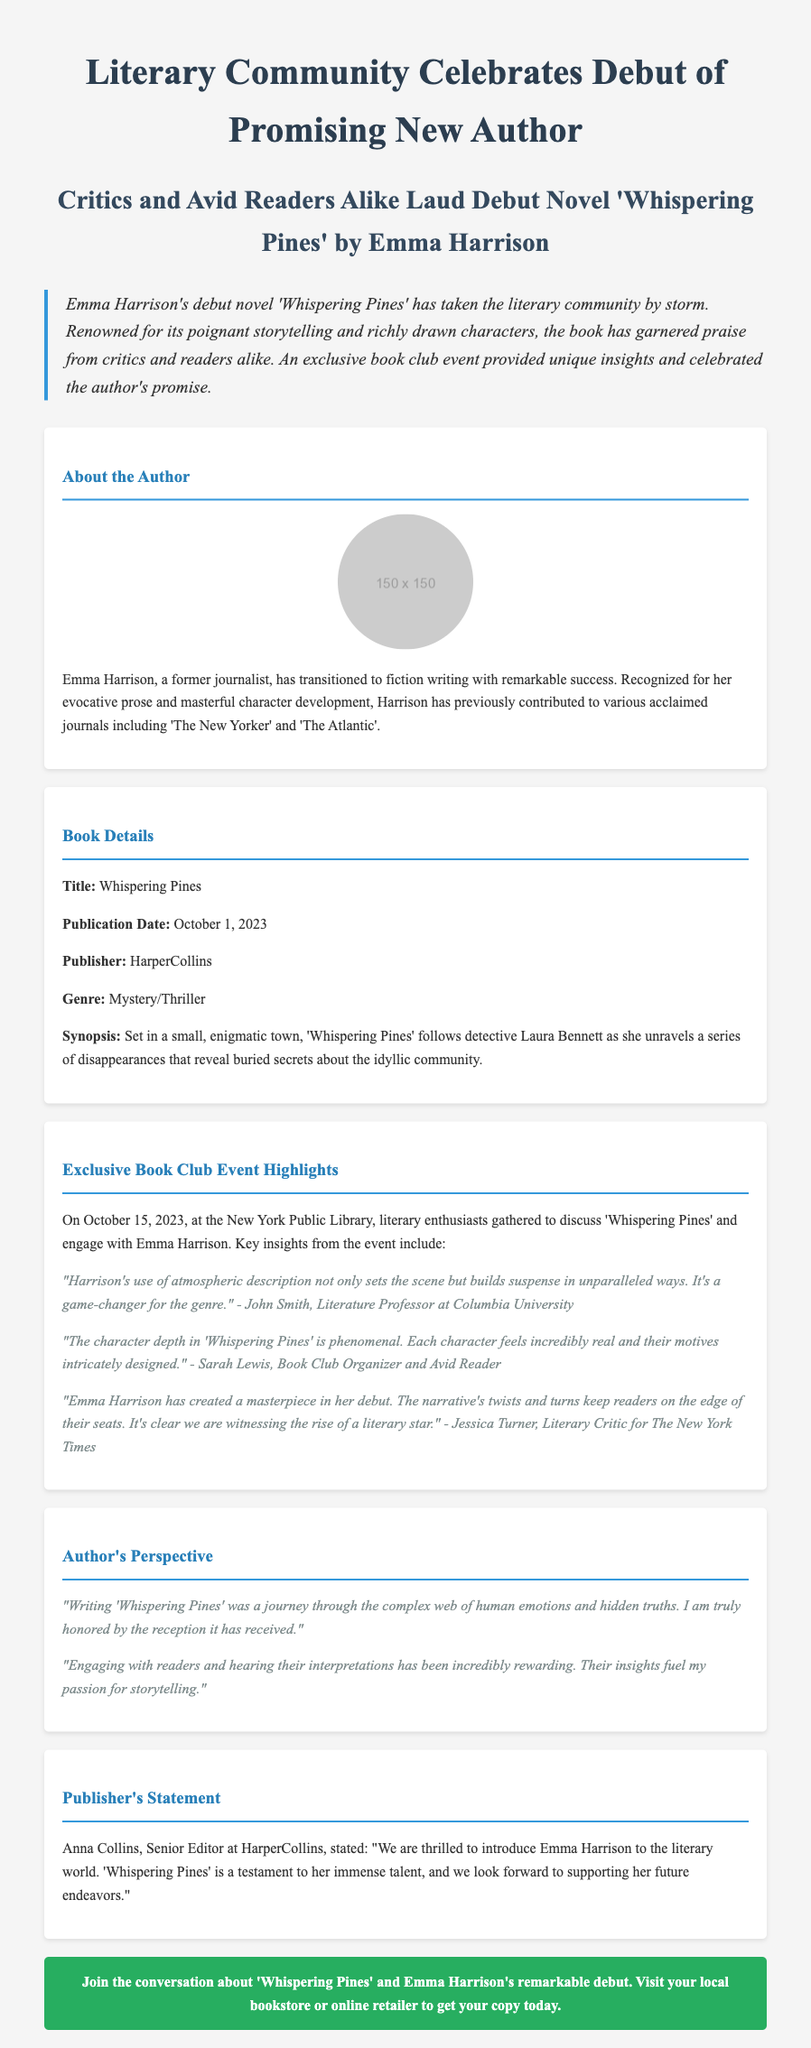What is the title of Emma Harrison's debut novel? The title of Emma Harrison's debut novel is explicitly stated in the document as 'Whispering Pines'.
Answer: Whispering Pines When was 'Whispering Pines' published? The publication date for 'Whispering Pines' is mentioned as October 1, 2023.
Answer: October 1, 2023 Who published 'Whispering Pines'? The publisher of the book is identified in the document as HarperCollins.
Answer: HarperCollins What genre does 'Whispering Pines' belong to? The genre of the novel is clearly categorized in the document as Mystery/Thriller.
Answer: Mystery/Thriller What event was held to celebrate the debut of Emma Harrison? The document notes that an exclusive book club event was held at the New York Public Library.
Answer: New York Public Library What key insight did John Smith share about 'Whispering Pines'? John Smith mentioned that Harrison's atmospheric description builds suspense in unparalleled ways.
Answer: Builds suspense in unparalleled ways What did Emma Harrison express about engaging with readers? Emma Harrison stated that hearing readers' interpretations has been incredibly rewarding.
Answer: Incredibly rewarding Who is Anna Collins? Anna Collins is introduced in the document as the Senior Editor at HarperCollins.
Answer: Senior Editor at HarperCollins What is the significance of the exclusive book club event? The event provided unique insights and celebrated the author's promise according to the document.
Answer: Celebrated the author's promise 